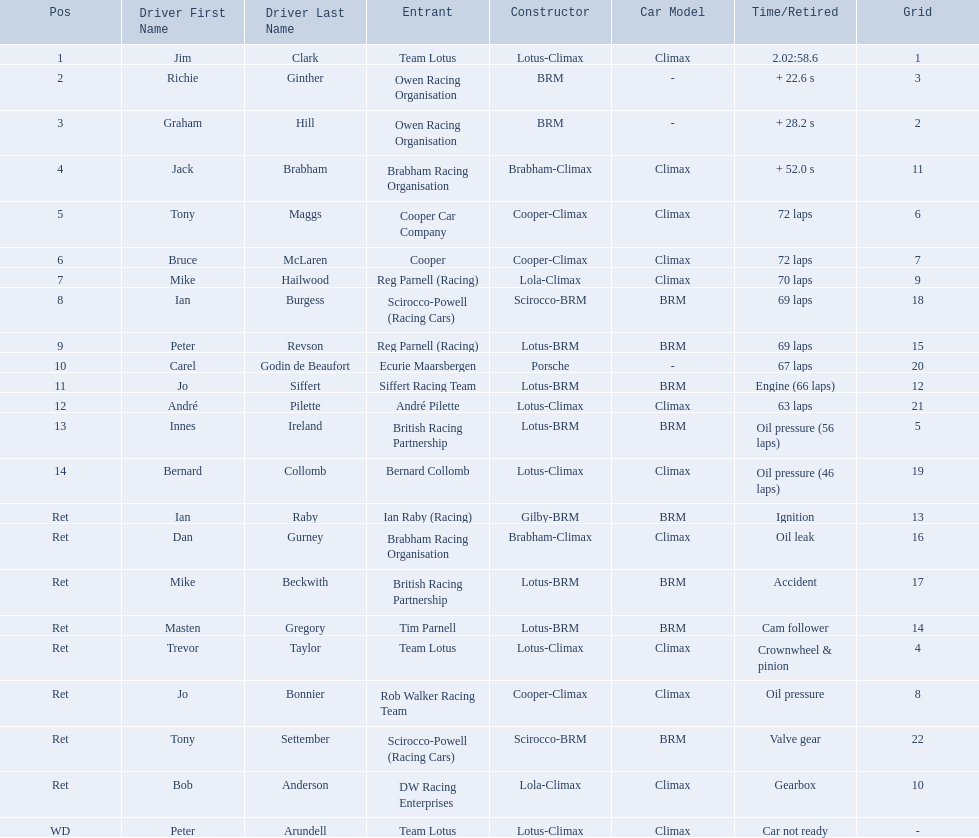Who are all the drivers? Jim Clark, Richie Ginther, Graham Hill, Jack Brabham, Tony Maggs, Bruce McLaren, Mike Hailwood, Ian Burgess, Peter Revson, Carel Godin de Beaufort, Jo Siffert, André Pilette, Innes Ireland, Bernard Collomb, Ian Raby, Dan Gurney, Mike Beckwith, Masten Gregory, Trevor Taylor, Jo Bonnier, Tony Settember, Bob Anderson, Peter Arundell. Which drove a cooper-climax? Tony Maggs, Bruce McLaren, Jo Bonnier. Of those, who was the top finisher? Tony Maggs. 